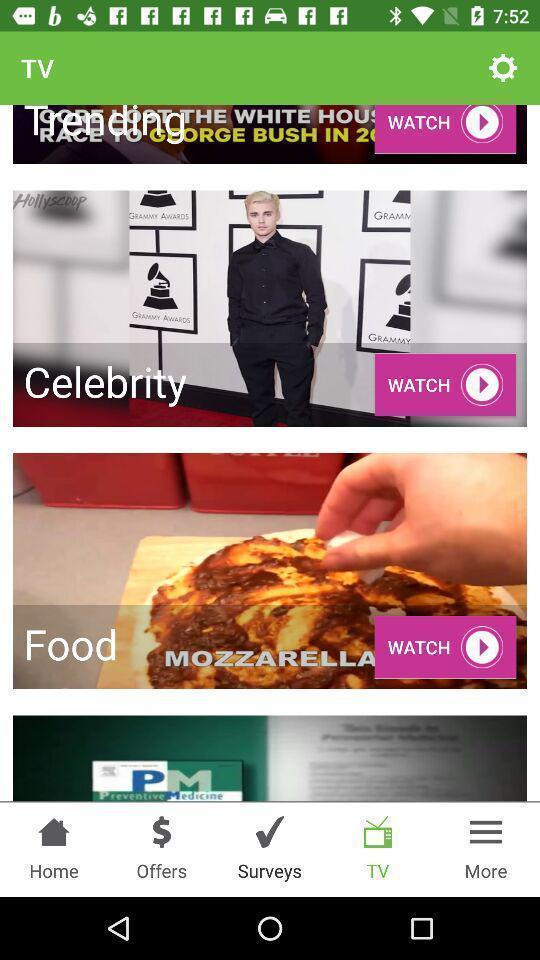Provide a description of this screenshot. Screen shows different options in application. 